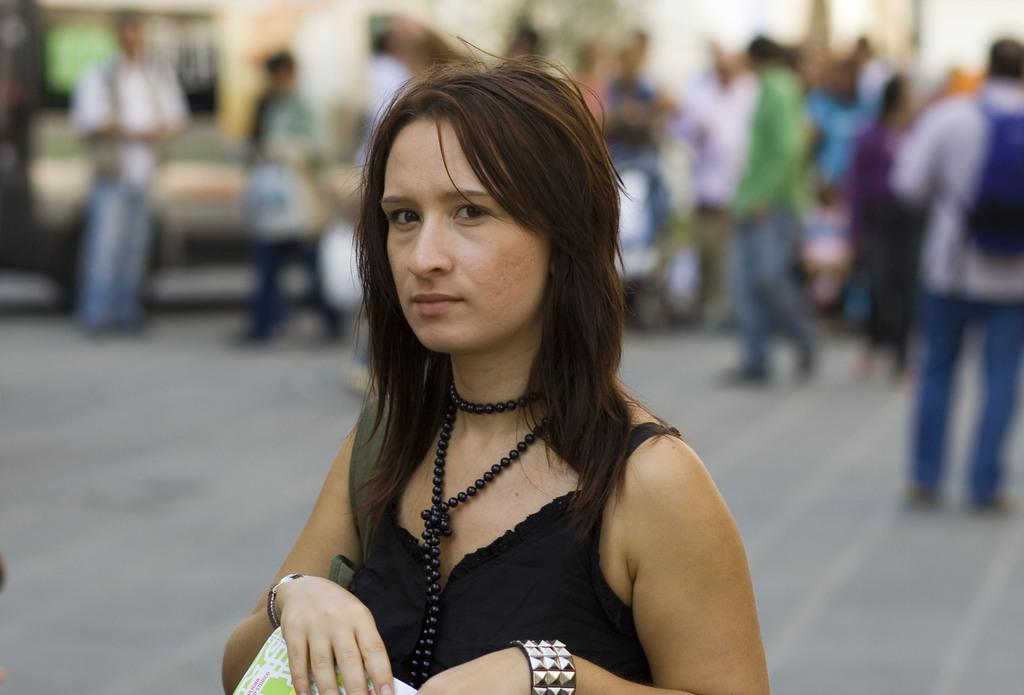What is the woman holding in the image? The woman is holding an object in the image. Can you describe the background of the image? The background is blurry in the image. Are there any other people visible in the image? Yes, there are people visible in the background of the image. What grade did the snail receive in the image? There is no snail present in the image, and therefore no grade can be assigned. 